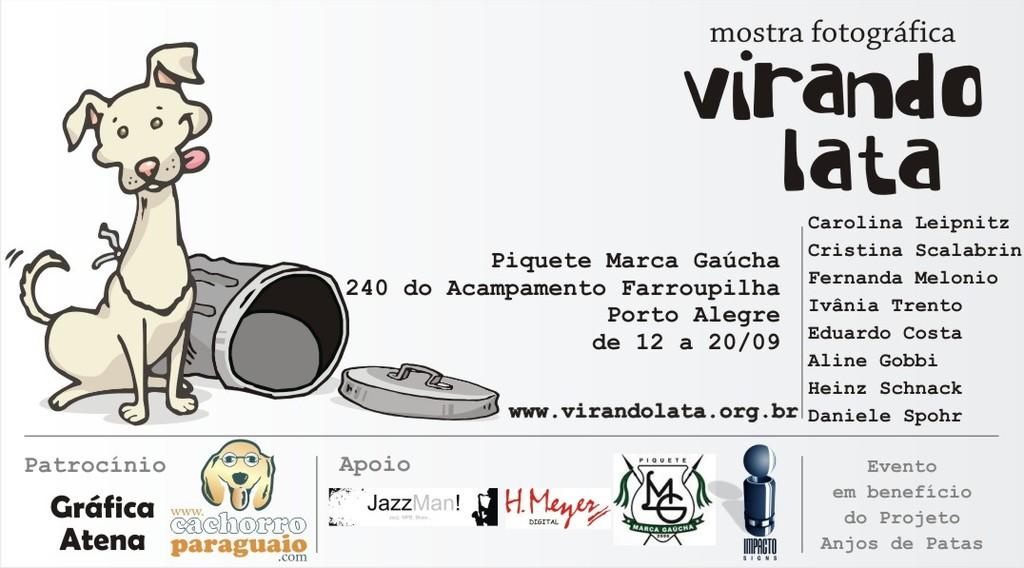What type of visual is the image? The image appears to be a poster. What can be seen on the poster? There are pictures and text on the poster. Is there any branding or identification on the poster? Yes, there is a logo on the poster. What time is depicted on the poster? There is no specific time depicted on the poster, as it is a visual representation with pictures, text, and a logo. Can you see any needles on the poster? There are no needles present on the poster. 